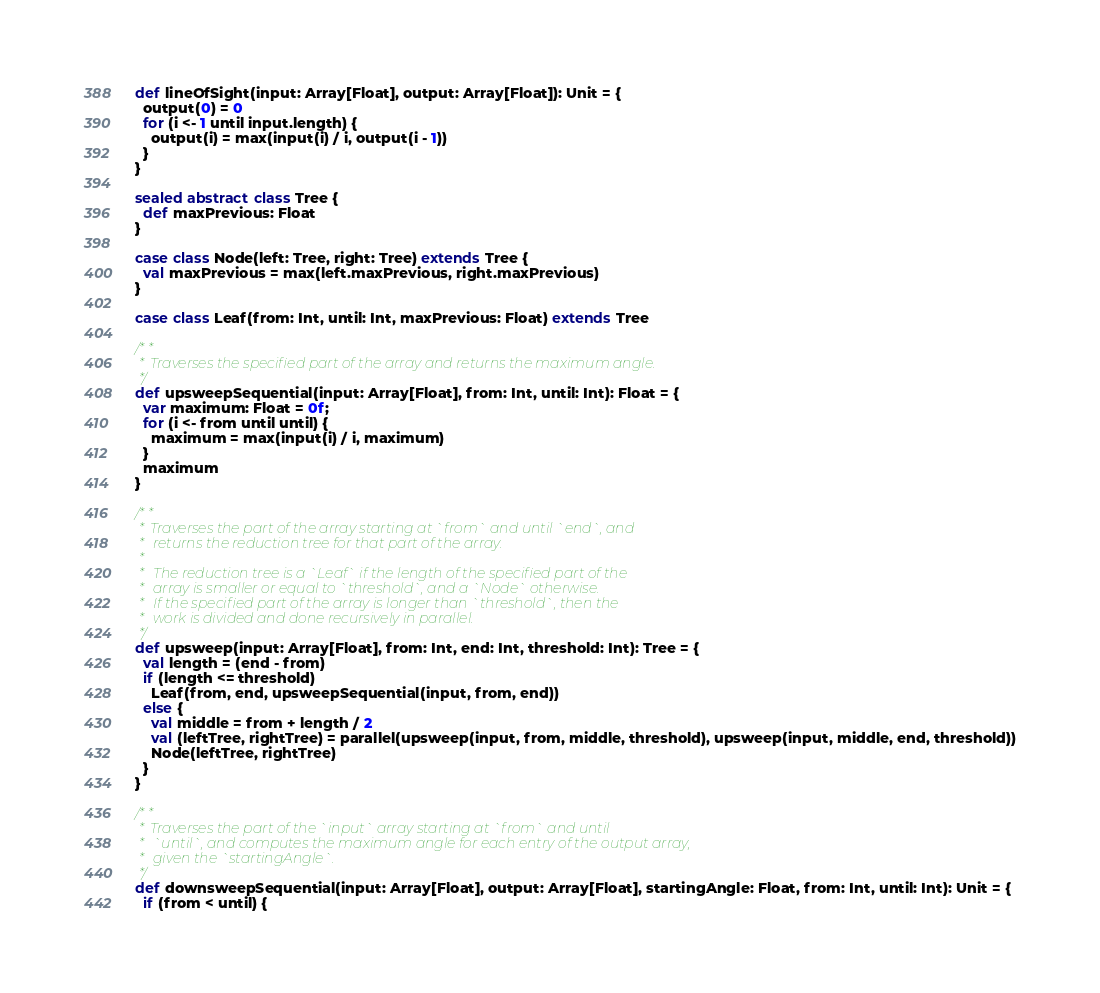<code> <loc_0><loc_0><loc_500><loc_500><_Scala_>
  def lineOfSight(input: Array[Float], output: Array[Float]): Unit = {
    output(0) = 0
    for (i <- 1 until input.length) {
      output(i) = max(input(i) / i, output(i - 1))
    }
  }

  sealed abstract class Tree {
    def maxPrevious: Float
  }

  case class Node(left: Tree, right: Tree) extends Tree {
    val maxPrevious = max(left.maxPrevious, right.maxPrevious)
  }

  case class Leaf(from: Int, until: Int, maxPrevious: Float) extends Tree

  /**
   * Traverses the specified part of the array and returns the maximum angle.
   */
  def upsweepSequential(input: Array[Float], from: Int, until: Int): Float = {
    var maximum: Float = 0f;
    for (i <- from until until) {
      maximum = max(input(i) / i, maximum)
    }
    maximum
  }

  /**
   * Traverses the part of the array starting at `from` and until `end`, and
   *  returns the reduction tree for that part of the array.
   *
   *  The reduction tree is a `Leaf` if the length of the specified part of the
   *  array is smaller or equal to `threshold`, and a `Node` otherwise.
   *  If the specified part of the array is longer than `threshold`, then the
   *  work is divided and done recursively in parallel.
   */
  def upsweep(input: Array[Float], from: Int, end: Int, threshold: Int): Tree = {
    val length = (end - from)
    if (length <= threshold) 
      Leaf(from, end, upsweepSequential(input, from, end))
    else {
      val middle = from + length / 2
      val (leftTree, rightTree) = parallel(upsweep(input, from, middle, threshold), upsweep(input, middle, end, threshold))
      Node(leftTree, rightTree)
    }
  }

  /**
   * Traverses the part of the `input` array starting at `from` and until
   *  `until`, and computes the maximum angle for each entry of the output array,
   *  given the `startingAngle`.
   */
  def downsweepSequential(input: Array[Float], output: Array[Float], startingAngle: Float, from: Int, until: Int): Unit = {
    if (from < until) {</code> 